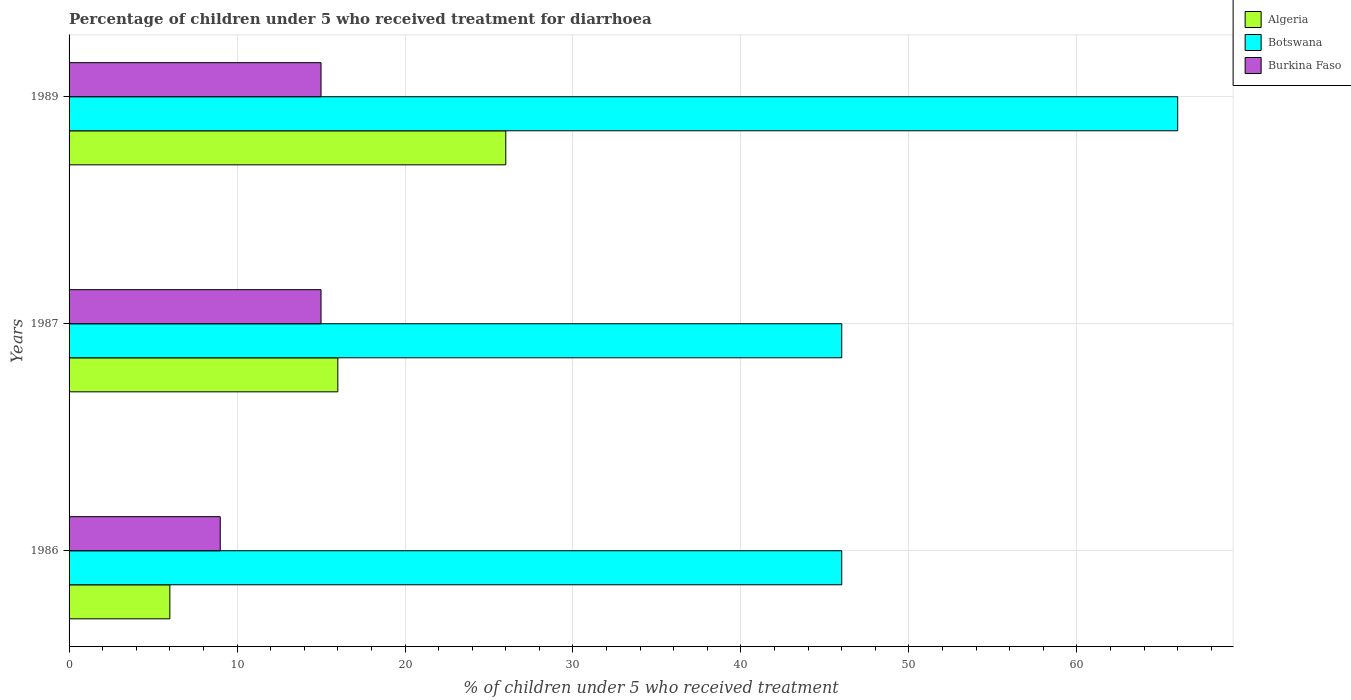How many different coloured bars are there?
Your answer should be very brief. 3. Are the number of bars on each tick of the Y-axis equal?
Give a very brief answer. Yes. How many bars are there on the 1st tick from the top?
Your response must be concise. 3. How many bars are there on the 3rd tick from the bottom?
Provide a succinct answer. 3. In how many cases, is the number of bars for a given year not equal to the number of legend labels?
Your response must be concise. 0. Across all years, what is the maximum percentage of children who received treatment for diarrhoea  in Botswana?
Your answer should be very brief. 66. Across all years, what is the minimum percentage of children who received treatment for diarrhoea  in Burkina Faso?
Give a very brief answer. 9. In which year was the percentage of children who received treatment for diarrhoea  in Burkina Faso maximum?
Your answer should be very brief. 1987. In which year was the percentage of children who received treatment for diarrhoea  in Algeria minimum?
Your answer should be very brief. 1986. What is the total percentage of children who received treatment for diarrhoea  in Burkina Faso in the graph?
Provide a short and direct response. 39. What is the difference between the percentage of children who received treatment for diarrhoea  in Algeria in 1986 and that in 1989?
Give a very brief answer. -20. What is the difference between the percentage of children who received treatment for diarrhoea  in Botswana in 1987 and the percentage of children who received treatment for diarrhoea  in Burkina Faso in 1989?
Make the answer very short. 31. What is the average percentage of children who received treatment for diarrhoea  in Algeria per year?
Provide a short and direct response. 16. In the year 1986, what is the difference between the percentage of children who received treatment for diarrhoea  in Burkina Faso and percentage of children who received treatment for diarrhoea  in Algeria?
Give a very brief answer. 3. In how many years, is the percentage of children who received treatment for diarrhoea  in Burkina Faso greater than 28 %?
Provide a succinct answer. 0. What is the ratio of the percentage of children who received treatment for diarrhoea  in Algeria in 1987 to that in 1989?
Provide a succinct answer. 0.62. Is the difference between the percentage of children who received treatment for diarrhoea  in Burkina Faso in 1986 and 1987 greater than the difference between the percentage of children who received treatment for diarrhoea  in Algeria in 1986 and 1987?
Offer a terse response. Yes. What is the difference between the highest and the second highest percentage of children who received treatment for diarrhoea  in Burkina Faso?
Provide a short and direct response. 0. What is the difference between the highest and the lowest percentage of children who received treatment for diarrhoea  in Burkina Faso?
Your answer should be compact. 6. What does the 2nd bar from the top in 1987 represents?
Keep it short and to the point. Botswana. What does the 1st bar from the bottom in 1987 represents?
Your answer should be very brief. Algeria. Is it the case that in every year, the sum of the percentage of children who received treatment for diarrhoea  in Botswana and percentage of children who received treatment for diarrhoea  in Algeria is greater than the percentage of children who received treatment for diarrhoea  in Burkina Faso?
Your answer should be compact. Yes. How many bars are there?
Your answer should be compact. 9. Are all the bars in the graph horizontal?
Provide a succinct answer. Yes. Are the values on the major ticks of X-axis written in scientific E-notation?
Offer a terse response. No. Does the graph contain any zero values?
Offer a very short reply. No. Does the graph contain grids?
Your response must be concise. Yes. How are the legend labels stacked?
Ensure brevity in your answer.  Vertical. What is the title of the graph?
Your answer should be very brief. Percentage of children under 5 who received treatment for diarrhoea. Does "Congo (Democratic)" appear as one of the legend labels in the graph?
Give a very brief answer. No. What is the label or title of the X-axis?
Give a very brief answer. % of children under 5 who received treatment. What is the label or title of the Y-axis?
Give a very brief answer. Years. What is the % of children under 5 who received treatment in Botswana in 1986?
Make the answer very short. 46. What is the % of children under 5 who received treatment of Burkina Faso in 1987?
Give a very brief answer. 15. What is the % of children under 5 who received treatment of Botswana in 1989?
Provide a short and direct response. 66. Across all years, what is the maximum % of children under 5 who received treatment in Burkina Faso?
Make the answer very short. 15. What is the total % of children under 5 who received treatment of Algeria in the graph?
Provide a succinct answer. 48. What is the total % of children under 5 who received treatment in Botswana in the graph?
Your answer should be very brief. 158. What is the difference between the % of children under 5 who received treatment of Burkina Faso in 1986 and that in 1987?
Your answer should be compact. -6. What is the difference between the % of children under 5 who received treatment of Algeria in 1986 and that in 1989?
Ensure brevity in your answer.  -20. What is the difference between the % of children under 5 who received treatment in Botswana in 1986 and that in 1989?
Your answer should be very brief. -20. What is the difference between the % of children under 5 who received treatment of Algeria in 1987 and that in 1989?
Give a very brief answer. -10. What is the difference between the % of children under 5 who received treatment in Botswana in 1987 and that in 1989?
Ensure brevity in your answer.  -20. What is the difference between the % of children under 5 who received treatment in Burkina Faso in 1987 and that in 1989?
Keep it short and to the point. 0. What is the difference between the % of children under 5 who received treatment in Botswana in 1986 and the % of children under 5 who received treatment in Burkina Faso in 1987?
Your answer should be very brief. 31. What is the difference between the % of children under 5 who received treatment of Algeria in 1986 and the % of children under 5 who received treatment of Botswana in 1989?
Ensure brevity in your answer.  -60. What is the difference between the % of children under 5 who received treatment of Algeria in 1987 and the % of children under 5 who received treatment of Botswana in 1989?
Offer a very short reply. -50. What is the difference between the % of children under 5 who received treatment in Algeria in 1987 and the % of children under 5 who received treatment in Burkina Faso in 1989?
Keep it short and to the point. 1. What is the difference between the % of children under 5 who received treatment of Botswana in 1987 and the % of children under 5 who received treatment of Burkina Faso in 1989?
Give a very brief answer. 31. What is the average % of children under 5 who received treatment in Algeria per year?
Keep it short and to the point. 16. What is the average % of children under 5 who received treatment of Botswana per year?
Offer a terse response. 52.67. In the year 1986, what is the difference between the % of children under 5 who received treatment in Algeria and % of children under 5 who received treatment in Botswana?
Keep it short and to the point. -40. In the year 1986, what is the difference between the % of children under 5 who received treatment of Algeria and % of children under 5 who received treatment of Burkina Faso?
Your response must be concise. -3. In the year 1987, what is the difference between the % of children under 5 who received treatment in Algeria and % of children under 5 who received treatment in Botswana?
Provide a short and direct response. -30. In the year 1987, what is the difference between the % of children under 5 who received treatment in Algeria and % of children under 5 who received treatment in Burkina Faso?
Offer a very short reply. 1. In the year 1989, what is the difference between the % of children under 5 who received treatment in Algeria and % of children under 5 who received treatment in Burkina Faso?
Your answer should be very brief. 11. In the year 1989, what is the difference between the % of children under 5 who received treatment in Botswana and % of children under 5 who received treatment in Burkina Faso?
Provide a succinct answer. 51. What is the ratio of the % of children under 5 who received treatment of Algeria in 1986 to that in 1987?
Offer a very short reply. 0.38. What is the ratio of the % of children under 5 who received treatment in Algeria in 1986 to that in 1989?
Make the answer very short. 0.23. What is the ratio of the % of children under 5 who received treatment of Botswana in 1986 to that in 1989?
Your answer should be very brief. 0.7. What is the ratio of the % of children under 5 who received treatment in Burkina Faso in 1986 to that in 1989?
Provide a succinct answer. 0.6. What is the ratio of the % of children under 5 who received treatment in Algeria in 1987 to that in 1989?
Ensure brevity in your answer.  0.62. What is the ratio of the % of children under 5 who received treatment of Botswana in 1987 to that in 1989?
Give a very brief answer. 0.7. What is the ratio of the % of children under 5 who received treatment in Burkina Faso in 1987 to that in 1989?
Keep it short and to the point. 1. What is the difference between the highest and the second highest % of children under 5 who received treatment in Burkina Faso?
Provide a succinct answer. 0. What is the difference between the highest and the lowest % of children under 5 who received treatment in Algeria?
Your response must be concise. 20. What is the difference between the highest and the lowest % of children under 5 who received treatment in Botswana?
Provide a short and direct response. 20. 